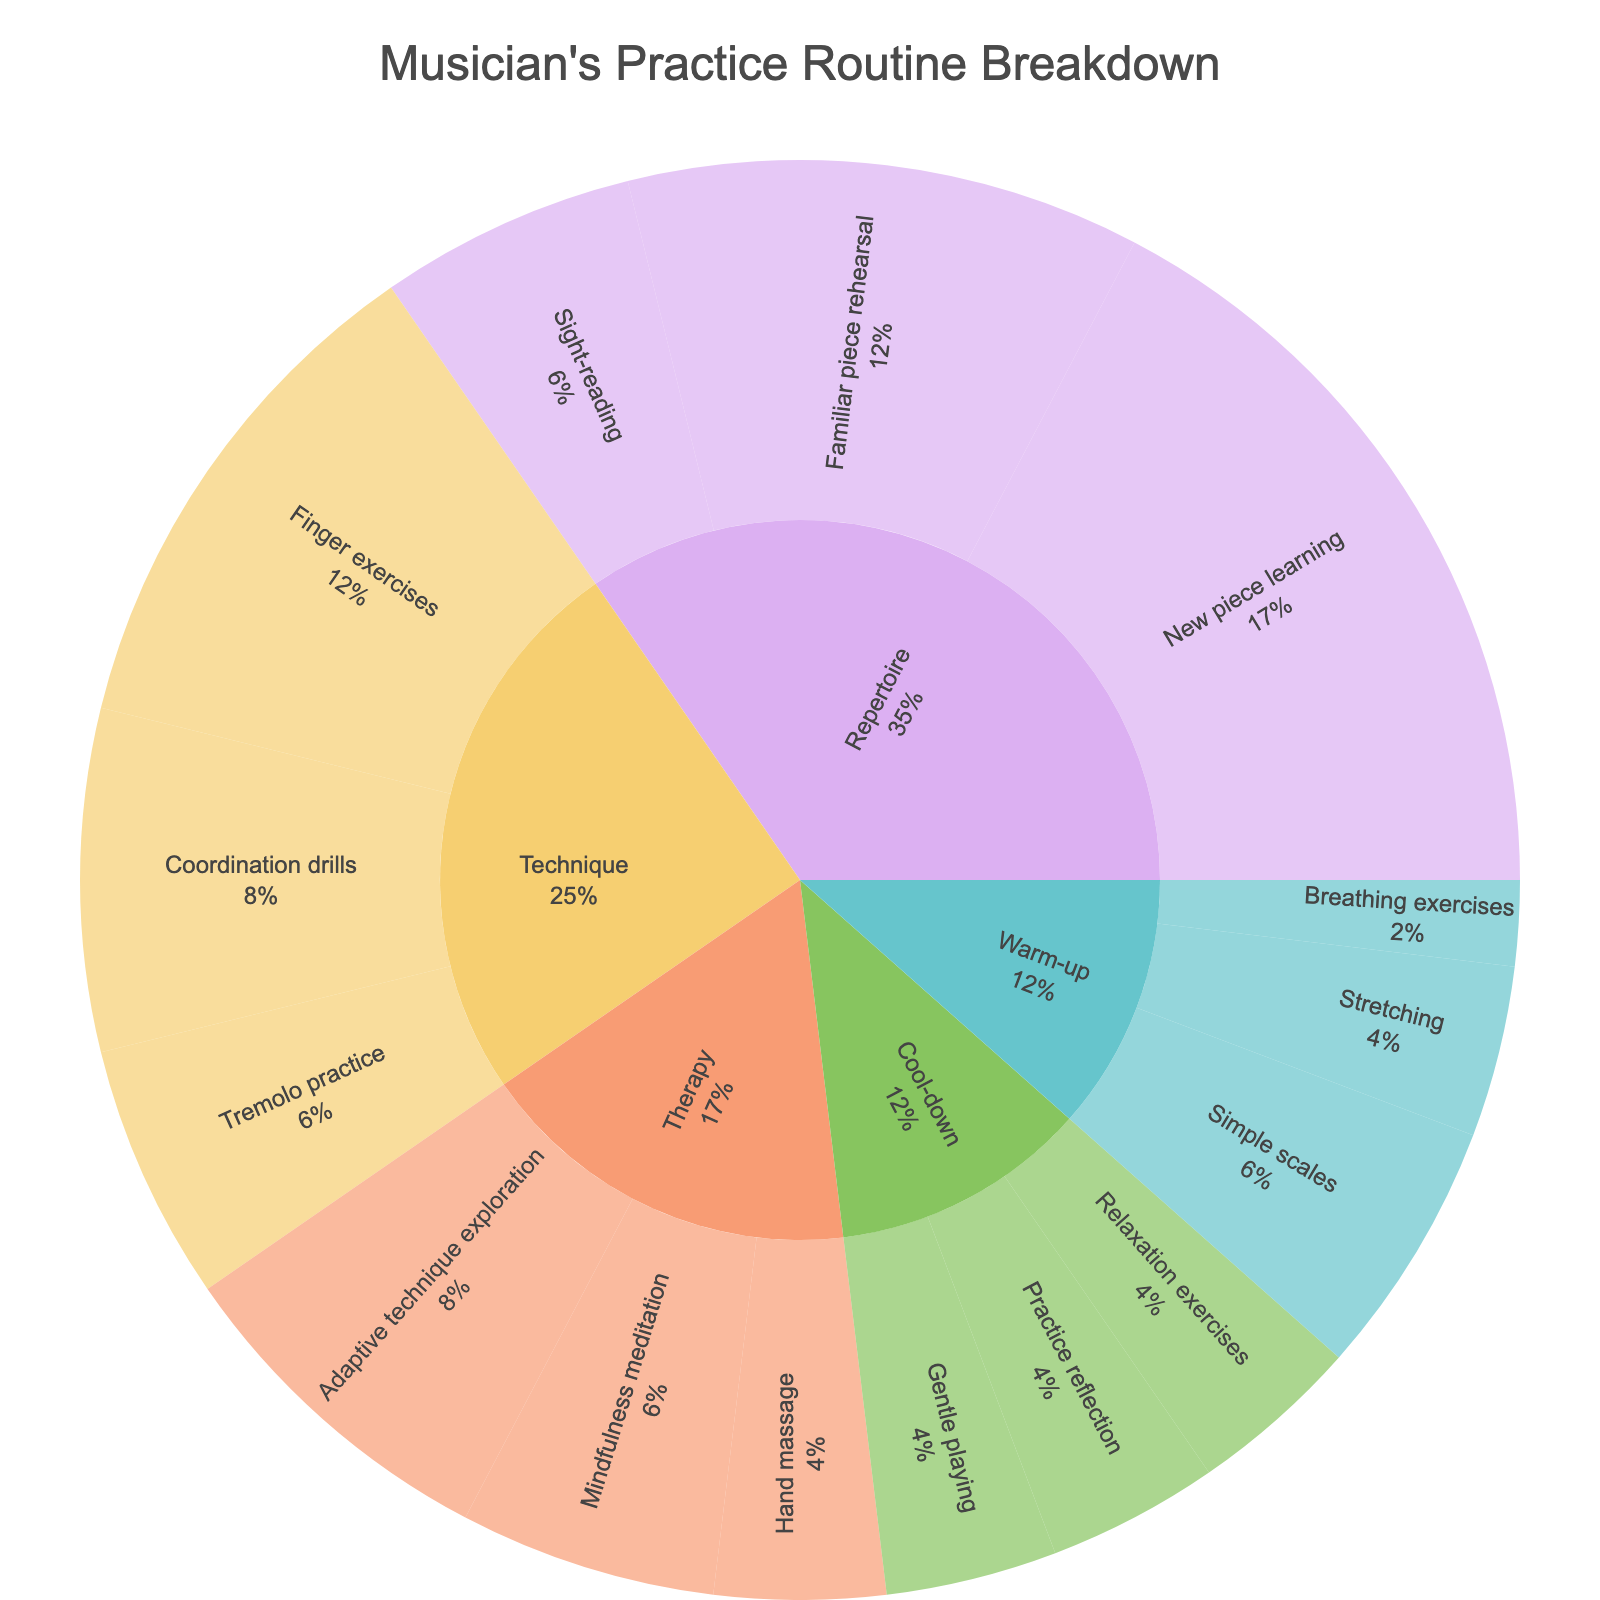How much total time is spent on warm-up activities? Add up the time spent on the subcategories under "Warm-up": Stretching (10 minutes), Breathing exercises (5 minutes), and Simple scales (15 minutes). So, 10 + 5 + 15 = 30 minutes.
Answer: 30 minutes Which activity has the highest time allocation in the musician's practice routine? Examine the parent categories in the Sunburst Plot and find the activity with the largest proportion. Repertoire has the biggest segment.
Answer: Repertoire How does the time spent on Therapy compare to the time spent on Technique? Calculate the total time for both Therapy and Technique. Therapy: 10 (Hand massage) + 15 (Mindfulness meditation) + 20 (Adaptive technique exploration) = 45 minutes. Technique: 30 (Finger exercises) + 20 (Coordination drills) + 15 (Tremolo practice) = 65 minutes. Compare 45 minutes and 65 minutes.
Answer: Technique has 20 more minutes than Therapy What is the percentage of time allocated to Coordination drills within Technique activities? Find the time spent on Coordination drills (20 minutes). Sum the time for all Technique activities (65 minutes). Calculate the percentage: (20/65) * 100 ≈ 30.77%.
Answer: ≈30.77% Which activity type includes both Finger exercises and Tremolo practice? The sunburst plot's structure shows that Finger exercises and Tremolo practice are both subcategories under Technique.
Answer: Technique What is the total time allocated to Therapy and Cool-down combined? Add the total time for Therapy (10 + 15 + 20 = 45 minutes) and Cool-down (10 + 10 + 10 = 30 minutes). So, 45 + 30 = 75 minutes.
Answer: 75 minutes Which specific practice category takes up the least time? Look at the subcategories and find the one with the smallest time allocation. Breathing exercises under Warm-up has only 5 minutes.
Answer: Breathing exercises Is more time spent on learning new pieces or rehearsing familiar pieces? Compare the time allocated to "New piece learning" (45 minutes) and "Familiar piece rehearsal" (30 minutes).
Answer: More time on learning new pieces (45 minutes) What percentage of the total practice routine is dedicated to Cool-down activities? Sum the entire practice routine time and the Cool-down activity time. Total: 10 (Stretching) + 5 (Breathing exercises) + 15 (Simple scales) + 30 (Finger exercises) + 20 (Coordination drills) + 15 (Tremolo practice) + 45 (New piece learning) + 30 (Familiar piece rehearsal) + 15 (Sight-reading) + 10 (Hand massage) + 15 (Mindfulness meditation) + 20 (Adaptive technique exploration) + 10 (Gentle playing) + 10 (Relaxation exercises) + 10 (Practice reflection) = 300 minutes. Cool-down: 10 + 10 + 10 = 30 minutes. Percentage: (30/300) * 100 = 10%.
Answer: 10% What is the step-by-step time distribution for New piece learning, Familiar piece rehearsal, and Sight-reading? List the given times for each subcategory under Repertoire. New piece learning: 45 minutes, Familiar piece rehearsal: 30 minutes, Sight-reading: 15 minutes.
Answer: New piece learning: 45 minutes, Familiar piece rehearsal: 30 minutes, Sight-reading: 15 minutes 